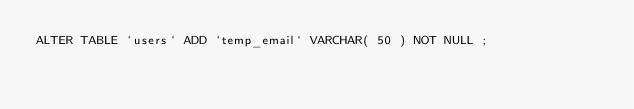Convert code to text. <code><loc_0><loc_0><loc_500><loc_500><_SQL_>ALTER TABLE `users` ADD `temp_email` VARCHAR( 50 ) NOT NULL ;
</code> 